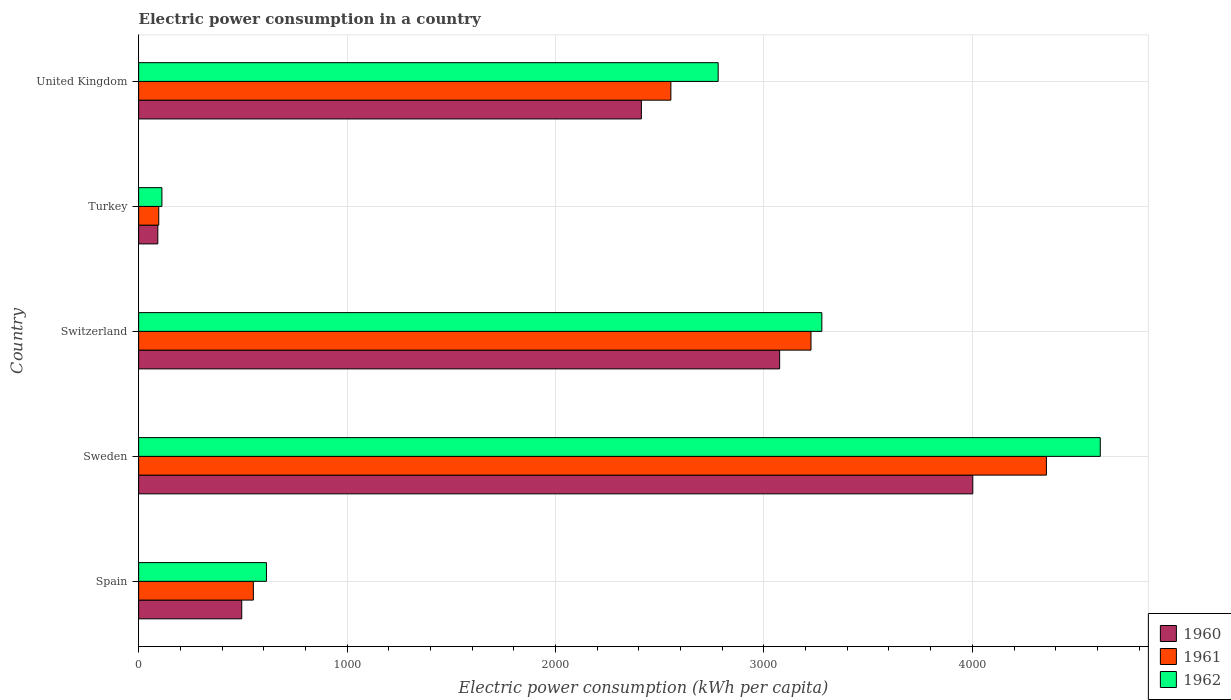How many groups of bars are there?
Your response must be concise. 5. Are the number of bars per tick equal to the number of legend labels?
Make the answer very short. Yes. How many bars are there on the 4th tick from the bottom?
Give a very brief answer. 3. In how many cases, is the number of bars for a given country not equal to the number of legend labels?
Give a very brief answer. 0. What is the electric power consumption in in 1960 in United Kingdom?
Offer a terse response. 2412.14. Across all countries, what is the maximum electric power consumption in in 1960?
Give a very brief answer. 4002.32. Across all countries, what is the minimum electric power consumption in in 1960?
Provide a succinct answer. 92.04. What is the total electric power consumption in in 1961 in the graph?
Ensure brevity in your answer.  1.08e+04. What is the difference between the electric power consumption in in 1960 in Spain and that in Turkey?
Ensure brevity in your answer.  402.76. What is the difference between the electric power consumption in in 1962 in United Kingdom and the electric power consumption in in 1960 in Sweden?
Provide a short and direct response. -1221.66. What is the average electric power consumption in in 1961 per country?
Offer a terse response. 2156.44. What is the difference between the electric power consumption in in 1960 and electric power consumption in in 1962 in United Kingdom?
Offer a very short reply. -368.52. What is the ratio of the electric power consumption in in 1962 in Switzerland to that in Turkey?
Offer a terse response. 29.33. What is the difference between the highest and the second highest electric power consumption in in 1960?
Make the answer very short. 926.77. What is the difference between the highest and the lowest electric power consumption in in 1962?
Your response must be concise. 4502.22. In how many countries, is the electric power consumption in in 1960 greater than the average electric power consumption in in 1960 taken over all countries?
Ensure brevity in your answer.  3. Is it the case that in every country, the sum of the electric power consumption in in 1962 and electric power consumption in in 1961 is greater than the electric power consumption in in 1960?
Provide a succinct answer. Yes. How many bars are there?
Make the answer very short. 15. Are all the bars in the graph horizontal?
Make the answer very short. Yes. How many countries are there in the graph?
Offer a very short reply. 5. Does the graph contain any zero values?
Provide a short and direct response. No. Where does the legend appear in the graph?
Provide a short and direct response. Bottom right. What is the title of the graph?
Ensure brevity in your answer.  Electric power consumption in a country. Does "1964" appear as one of the legend labels in the graph?
Your response must be concise. No. What is the label or title of the X-axis?
Provide a succinct answer. Electric power consumption (kWh per capita). What is the Electric power consumption (kWh per capita) of 1960 in Spain?
Your answer should be very brief. 494.8. What is the Electric power consumption (kWh per capita) of 1961 in Spain?
Give a very brief answer. 550.44. What is the Electric power consumption (kWh per capita) in 1962 in Spain?
Offer a very short reply. 613.25. What is the Electric power consumption (kWh per capita) in 1960 in Sweden?
Offer a very short reply. 4002.32. What is the Electric power consumption (kWh per capita) of 1961 in Sweden?
Your response must be concise. 4355.45. What is the Electric power consumption (kWh per capita) in 1962 in Sweden?
Make the answer very short. 4613.98. What is the Electric power consumption (kWh per capita) in 1960 in Switzerland?
Ensure brevity in your answer.  3075.55. What is the Electric power consumption (kWh per capita) of 1961 in Switzerland?
Ensure brevity in your answer.  3225.99. What is the Electric power consumption (kWh per capita) in 1962 in Switzerland?
Your answer should be compact. 3278.01. What is the Electric power consumption (kWh per capita) in 1960 in Turkey?
Offer a very short reply. 92.04. What is the Electric power consumption (kWh per capita) in 1961 in Turkey?
Offer a terse response. 96.64. What is the Electric power consumption (kWh per capita) of 1962 in Turkey?
Offer a very short reply. 111.76. What is the Electric power consumption (kWh per capita) of 1960 in United Kingdom?
Provide a short and direct response. 2412.14. What is the Electric power consumption (kWh per capita) of 1961 in United Kingdom?
Provide a succinct answer. 2553.69. What is the Electric power consumption (kWh per capita) in 1962 in United Kingdom?
Offer a very short reply. 2780.66. Across all countries, what is the maximum Electric power consumption (kWh per capita) in 1960?
Offer a very short reply. 4002.32. Across all countries, what is the maximum Electric power consumption (kWh per capita) of 1961?
Your answer should be compact. 4355.45. Across all countries, what is the maximum Electric power consumption (kWh per capita) of 1962?
Provide a short and direct response. 4613.98. Across all countries, what is the minimum Electric power consumption (kWh per capita) of 1960?
Offer a very short reply. 92.04. Across all countries, what is the minimum Electric power consumption (kWh per capita) in 1961?
Your response must be concise. 96.64. Across all countries, what is the minimum Electric power consumption (kWh per capita) of 1962?
Ensure brevity in your answer.  111.76. What is the total Electric power consumption (kWh per capita) of 1960 in the graph?
Your response must be concise. 1.01e+04. What is the total Electric power consumption (kWh per capita) of 1961 in the graph?
Offer a terse response. 1.08e+04. What is the total Electric power consumption (kWh per capita) in 1962 in the graph?
Your response must be concise. 1.14e+04. What is the difference between the Electric power consumption (kWh per capita) in 1960 in Spain and that in Sweden?
Ensure brevity in your answer.  -3507.53. What is the difference between the Electric power consumption (kWh per capita) of 1961 in Spain and that in Sweden?
Offer a very short reply. -3805.02. What is the difference between the Electric power consumption (kWh per capita) in 1962 in Spain and that in Sweden?
Ensure brevity in your answer.  -4000.73. What is the difference between the Electric power consumption (kWh per capita) in 1960 in Spain and that in Switzerland?
Offer a terse response. -2580.75. What is the difference between the Electric power consumption (kWh per capita) of 1961 in Spain and that in Switzerland?
Your answer should be very brief. -2675.56. What is the difference between the Electric power consumption (kWh per capita) of 1962 in Spain and that in Switzerland?
Make the answer very short. -2664.76. What is the difference between the Electric power consumption (kWh per capita) in 1960 in Spain and that in Turkey?
Your response must be concise. 402.76. What is the difference between the Electric power consumption (kWh per capita) of 1961 in Spain and that in Turkey?
Offer a terse response. 453.8. What is the difference between the Electric power consumption (kWh per capita) in 1962 in Spain and that in Turkey?
Your response must be concise. 501.49. What is the difference between the Electric power consumption (kWh per capita) of 1960 in Spain and that in United Kingdom?
Offer a very short reply. -1917.34. What is the difference between the Electric power consumption (kWh per capita) in 1961 in Spain and that in United Kingdom?
Provide a succinct answer. -2003.26. What is the difference between the Electric power consumption (kWh per capita) of 1962 in Spain and that in United Kingdom?
Give a very brief answer. -2167.41. What is the difference between the Electric power consumption (kWh per capita) in 1960 in Sweden and that in Switzerland?
Your response must be concise. 926.77. What is the difference between the Electric power consumption (kWh per capita) of 1961 in Sweden and that in Switzerland?
Offer a terse response. 1129.46. What is the difference between the Electric power consumption (kWh per capita) of 1962 in Sweden and that in Switzerland?
Your answer should be very brief. 1335.97. What is the difference between the Electric power consumption (kWh per capita) of 1960 in Sweden and that in Turkey?
Give a very brief answer. 3910.28. What is the difference between the Electric power consumption (kWh per capita) in 1961 in Sweden and that in Turkey?
Your response must be concise. 4258.82. What is the difference between the Electric power consumption (kWh per capita) of 1962 in Sweden and that in Turkey?
Provide a short and direct response. 4502.22. What is the difference between the Electric power consumption (kWh per capita) in 1960 in Sweden and that in United Kingdom?
Make the answer very short. 1590.18. What is the difference between the Electric power consumption (kWh per capita) in 1961 in Sweden and that in United Kingdom?
Your response must be concise. 1801.76. What is the difference between the Electric power consumption (kWh per capita) in 1962 in Sweden and that in United Kingdom?
Offer a very short reply. 1833.32. What is the difference between the Electric power consumption (kWh per capita) in 1960 in Switzerland and that in Turkey?
Ensure brevity in your answer.  2983.51. What is the difference between the Electric power consumption (kWh per capita) in 1961 in Switzerland and that in Turkey?
Your response must be concise. 3129.36. What is the difference between the Electric power consumption (kWh per capita) of 1962 in Switzerland and that in Turkey?
Offer a terse response. 3166.25. What is the difference between the Electric power consumption (kWh per capita) in 1960 in Switzerland and that in United Kingdom?
Provide a short and direct response. 663.41. What is the difference between the Electric power consumption (kWh per capita) in 1961 in Switzerland and that in United Kingdom?
Provide a succinct answer. 672.3. What is the difference between the Electric power consumption (kWh per capita) in 1962 in Switzerland and that in United Kingdom?
Keep it short and to the point. 497.35. What is the difference between the Electric power consumption (kWh per capita) in 1960 in Turkey and that in United Kingdom?
Make the answer very short. -2320.1. What is the difference between the Electric power consumption (kWh per capita) in 1961 in Turkey and that in United Kingdom?
Offer a very short reply. -2457.06. What is the difference between the Electric power consumption (kWh per capita) of 1962 in Turkey and that in United Kingdom?
Make the answer very short. -2668.9. What is the difference between the Electric power consumption (kWh per capita) of 1960 in Spain and the Electric power consumption (kWh per capita) of 1961 in Sweden?
Keep it short and to the point. -3860.66. What is the difference between the Electric power consumption (kWh per capita) of 1960 in Spain and the Electric power consumption (kWh per capita) of 1962 in Sweden?
Keep it short and to the point. -4119.18. What is the difference between the Electric power consumption (kWh per capita) of 1961 in Spain and the Electric power consumption (kWh per capita) of 1962 in Sweden?
Provide a succinct answer. -4063.54. What is the difference between the Electric power consumption (kWh per capita) of 1960 in Spain and the Electric power consumption (kWh per capita) of 1961 in Switzerland?
Your answer should be very brief. -2731.2. What is the difference between the Electric power consumption (kWh per capita) in 1960 in Spain and the Electric power consumption (kWh per capita) in 1962 in Switzerland?
Provide a short and direct response. -2783.21. What is the difference between the Electric power consumption (kWh per capita) of 1961 in Spain and the Electric power consumption (kWh per capita) of 1962 in Switzerland?
Ensure brevity in your answer.  -2727.57. What is the difference between the Electric power consumption (kWh per capita) in 1960 in Spain and the Electric power consumption (kWh per capita) in 1961 in Turkey?
Keep it short and to the point. 398.16. What is the difference between the Electric power consumption (kWh per capita) of 1960 in Spain and the Electric power consumption (kWh per capita) of 1962 in Turkey?
Provide a succinct answer. 383.03. What is the difference between the Electric power consumption (kWh per capita) in 1961 in Spain and the Electric power consumption (kWh per capita) in 1962 in Turkey?
Offer a very short reply. 438.68. What is the difference between the Electric power consumption (kWh per capita) of 1960 in Spain and the Electric power consumption (kWh per capita) of 1961 in United Kingdom?
Provide a succinct answer. -2058.9. What is the difference between the Electric power consumption (kWh per capita) in 1960 in Spain and the Electric power consumption (kWh per capita) in 1962 in United Kingdom?
Offer a very short reply. -2285.86. What is the difference between the Electric power consumption (kWh per capita) in 1961 in Spain and the Electric power consumption (kWh per capita) in 1962 in United Kingdom?
Your answer should be very brief. -2230.22. What is the difference between the Electric power consumption (kWh per capita) in 1960 in Sweden and the Electric power consumption (kWh per capita) in 1961 in Switzerland?
Provide a short and direct response. 776.33. What is the difference between the Electric power consumption (kWh per capita) in 1960 in Sweden and the Electric power consumption (kWh per capita) in 1962 in Switzerland?
Offer a very short reply. 724.32. What is the difference between the Electric power consumption (kWh per capita) of 1961 in Sweden and the Electric power consumption (kWh per capita) of 1962 in Switzerland?
Your answer should be compact. 1077.45. What is the difference between the Electric power consumption (kWh per capita) of 1960 in Sweden and the Electric power consumption (kWh per capita) of 1961 in Turkey?
Keep it short and to the point. 3905.68. What is the difference between the Electric power consumption (kWh per capita) of 1960 in Sweden and the Electric power consumption (kWh per capita) of 1962 in Turkey?
Ensure brevity in your answer.  3890.56. What is the difference between the Electric power consumption (kWh per capita) of 1961 in Sweden and the Electric power consumption (kWh per capita) of 1962 in Turkey?
Your response must be concise. 4243.69. What is the difference between the Electric power consumption (kWh per capita) of 1960 in Sweden and the Electric power consumption (kWh per capita) of 1961 in United Kingdom?
Your answer should be very brief. 1448.63. What is the difference between the Electric power consumption (kWh per capita) of 1960 in Sweden and the Electric power consumption (kWh per capita) of 1962 in United Kingdom?
Ensure brevity in your answer.  1221.66. What is the difference between the Electric power consumption (kWh per capita) in 1961 in Sweden and the Electric power consumption (kWh per capita) in 1962 in United Kingdom?
Your answer should be very brief. 1574.8. What is the difference between the Electric power consumption (kWh per capita) of 1960 in Switzerland and the Electric power consumption (kWh per capita) of 1961 in Turkey?
Give a very brief answer. 2978.91. What is the difference between the Electric power consumption (kWh per capita) of 1960 in Switzerland and the Electric power consumption (kWh per capita) of 1962 in Turkey?
Offer a terse response. 2963.79. What is the difference between the Electric power consumption (kWh per capita) of 1961 in Switzerland and the Electric power consumption (kWh per capita) of 1962 in Turkey?
Offer a terse response. 3114.23. What is the difference between the Electric power consumption (kWh per capita) of 1960 in Switzerland and the Electric power consumption (kWh per capita) of 1961 in United Kingdom?
Offer a terse response. 521.86. What is the difference between the Electric power consumption (kWh per capita) of 1960 in Switzerland and the Electric power consumption (kWh per capita) of 1962 in United Kingdom?
Ensure brevity in your answer.  294.89. What is the difference between the Electric power consumption (kWh per capita) in 1961 in Switzerland and the Electric power consumption (kWh per capita) in 1962 in United Kingdom?
Your answer should be very brief. 445.34. What is the difference between the Electric power consumption (kWh per capita) of 1960 in Turkey and the Electric power consumption (kWh per capita) of 1961 in United Kingdom?
Your answer should be very brief. -2461.65. What is the difference between the Electric power consumption (kWh per capita) of 1960 in Turkey and the Electric power consumption (kWh per capita) of 1962 in United Kingdom?
Offer a very short reply. -2688.62. What is the difference between the Electric power consumption (kWh per capita) of 1961 in Turkey and the Electric power consumption (kWh per capita) of 1962 in United Kingdom?
Keep it short and to the point. -2684.02. What is the average Electric power consumption (kWh per capita) of 1960 per country?
Make the answer very short. 2015.37. What is the average Electric power consumption (kWh per capita) of 1961 per country?
Make the answer very short. 2156.44. What is the average Electric power consumption (kWh per capita) in 1962 per country?
Your response must be concise. 2279.53. What is the difference between the Electric power consumption (kWh per capita) in 1960 and Electric power consumption (kWh per capita) in 1961 in Spain?
Offer a very short reply. -55.64. What is the difference between the Electric power consumption (kWh per capita) of 1960 and Electric power consumption (kWh per capita) of 1962 in Spain?
Provide a short and direct response. -118.45. What is the difference between the Electric power consumption (kWh per capita) in 1961 and Electric power consumption (kWh per capita) in 1962 in Spain?
Keep it short and to the point. -62.81. What is the difference between the Electric power consumption (kWh per capita) in 1960 and Electric power consumption (kWh per capita) in 1961 in Sweden?
Offer a terse response. -353.13. What is the difference between the Electric power consumption (kWh per capita) of 1960 and Electric power consumption (kWh per capita) of 1962 in Sweden?
Your answer should be compact. -611.66. What is the difference between the Electric power consumption (kWh per capita) in 1961 and Electric power consumption (kWh per capita) in 1962 in Sweden?
Offer a terse response. -258.52. What is the difference between the Electric power consumption (kWh per capita) of 1960 and Electric power consumption (kWh per capita) of 1961 in Switzerland?
Your response must be concise. -150.44. What is the difference between the Electric power consumption (kWh per capita) of 1960 and Electric power consumption (kWh per capita) of 1962 in Switzerland?
Keep it short and to the point. -202.46. What is the difference between the Electric power consumption (kWh per capita) in 1961 and Electric power consumption (kWh per capita) in 1962 in Switzerland?
Offer a very short reply. -52.01. What is the difference between the Electric power consumption (kWh per capita) of 1960 and Electric power consumption (kWh per capita) of 1961 in Turkey?
Your answer should be compact. -4.6. What is the difference between the Electric power consumption (kWh per capita) of 1960 and Electric power consumption (kWh per capita) of 1962 in Turkey?
Offer a very short reply. -19.72. What is the difference between the Electric power consumption (kWh per capita) in 1961 and Electric power consumption (kWh per capita) in 1962 in Turkey?
Your answer should be compact. -15.12. What is the difference between the Electric power consumption (kWh per capita) of 1960 and Electric power consumption (kWh per capita) of 1961 in United Kingdom?
Your answer should be compact. -141.56. What is the difference between the Electric power consumption (kWh per capita) of 1960 and Electric power consumption (kWh per capita) of 1962 in United Kingdom?
Provide a succinct answer. -368.52. What is the difference between the Electric power consumption (kWh per capita) in 1961 and Electric power consumption (kWh per capita) in 1962 in United Kingdom?
Provide a short and direct response. -226.96. What is the ratio of the Electric power consumption (kWh per capita) of 1960 in Spain to that in Sweden?
Keep it short and to the point. 0.12. What is the ratio of the Electric power consumption (kWh per capita) in 1961 in Spain to that in Sweden?
Give a very brief answer. 0.13. What is the ratio of the Electric power consumption (kWh per capita) in 1962 in Spain to that in Sweden?
Give a very brief answer. 0.13. What is the ratio of the Electric power consumption (kWh per capita) in 1960 in Spain to that in Switzerland?
Your answer should be very brief. 0.16. What is the ratio of the Electric power consumption (kWh per capita) in 1961 in Spain to that in Switzerland?
Make the answer very short. 0.17. What is the ratio of the Electric power consumption (kWh per capita) in 1962 in Spain to that in Switzerland?
Your answer should be very brief. 0.19. What is the ratio of the Electric power consumption (kWh per capita) in 1960 in Spain to that in Turkey?
Offer a terse response. 5.38. What is the ratio of the Electric power consumption (kWh per capita) in 1961 in Spain to that in Turkey?
Your answer should be compact. 5.7. What is the ratio of the Electric power consumption (kWh per capita) of 1962 in Spain to that in Turkey?
Your answer should be very brief. 5.49. What is the ratio of the Electric power consumption (kWh per capita) in 1960 in Spain to that in United Kingdom?
Provide a short and direct response. 0.21. What is the ratio of the Electric power consumption (kWh per capita) of 1961 in Spain to that in United Kingdom?
Your answer should be compact. 0.22. What is the ratio of the Electric power consumption (kWh per capita) in 1962 in Spain to that in United Kingdom?
Keep it short and to the point. 0.22. What is the ratio of the Electric power consumption (kWh per capita) in 1960 in Sweden to that in Switzerland?
Your answer should be compact. 1.3. What is the ratio of the Electric power consumption (kWh per capita) in 1961 in Sweden to that in Switzerland?
Ensure brevity in your answer.  1.35. What is the ratio of the Electric power consumption (kWh per capita) in 1962 in Sweden to that in Switzerland?
Provide a succinct answer. 1.41. What is the ratio of the Electric power consumption (kWh per capita) of 1960 in Sweden to that in Turkey?
Provide a succinct answer. 43.48. What is the ratio of the Electric power consumption (kWh per capita) in 1961 in Sweden to that in Turkey?
Your answer should be very brief. 45.07. What is the ratio of the Electric power consumption (kWh per capita) of 1962 in Sweden to that in Turkey?
Your response must be concise. 41.28. What is the ratio of the Electric power consumption (kWh per capita) in 1960 in Sweden to that in United Kingdom?
Your response must be concise. 1.66. What is the ratio of the Electric power consumption (kWh per capita) of 1961 in Sweden to that in United Kingdom?
Keep it short and to the point. 1.71. What is the ratio of the Electric power consumption (kWh per capita) of 1962 in Sweden to that in United Kingdom?
Give a very brief answer. 1.66. What is the ratio of the Electric power consumption (kWh per capita) of 1960 in Switzerland to that in Turkey?
Keep it short and to the point. 33.42. What is the ratio of the Electric power consumption (kWh per capita) of 1961 in Switzerland to that in Turkey?
Your answer should be compact. 33.38. What is the ratio of the Electric power consumption (kWh per capita) in 1962 in Switzerland to that in Turkey?
Keep it short and to the point. 29.33. What is the ratio of the Electric power consumption (kWh per capita) in 1960 in Switzerland to that in United Kingdom?
Offer a very short reply. 1.27. What is the ratio of the Electric power consumption (kWh per capita) in 1961 in Switzerland to that in United Kingdom?
Offer a very short reply. 1.26. What is the ratio of the Electric power consumption (kWh per capita) of 1962 in Switzerland to that in United Kingdom?
Provide a succinct answer. 1.18. What is the ratio of the Electric power consumption (kWh per capita) in 1960 in Turkey to that in United Kingdom?
Offer a terse response. 0.04. What is the ratio of the Electric power consumption (kWh per capita) of 1961 in Turkey to that in United Kingdom?
Provide a short and direct response. 0.04. What is the ratio of the Electric power consumption (kWh per capita) in 1962 in Turkey to that in United Kingdom?
Your answer should be very brief. 0.04. What is the difference between the highest and the second highest Electric power consumption (kWh per capita) in 1960?
Keep it short and to the point. 926.77. What is the difference between the highest and the second highest Electric power consumption (kWh per capita) in 1961?
Your answer should be compact. 1129.46. What is the difference between the highest and the second highest Electric power consumption (kWh per capita) in 1962?
Offer a terse response. 1335.97. What is the difference between the highest and the lowest Electric power consumption (kWh per capita) in 1960?
Your answer should be very brief. 3910.28. What is the difference between the highest and the lowest Electric power consumption (kWh per capita) in 1961?
Your answer should be very brief. 4258.82. What is the difference between the highest and the lowest Electric power consumption (kWh per capita) of 1962?
Provide a short and direct response. 4502.22. 